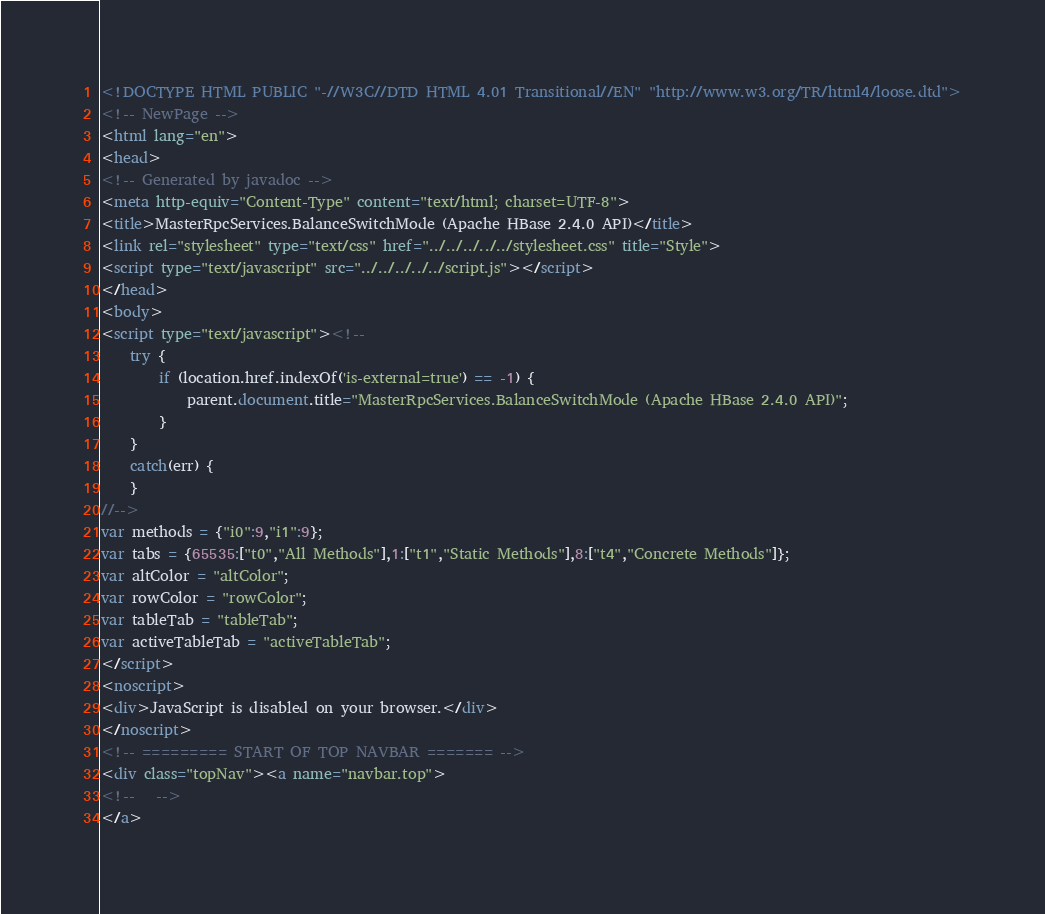Convert code to text. <code><loc_0><loc_0><loc_500><loc_500><_HTML_><!DOCTYPE HTML PUBLIC "-//W3C//DTD HTML 4.01 Transitional//EN" "http://www.w3.org/TR/html4/loose.dtd">
<!-- NewPage -->
<html lang="en">
<head>
<!-- Generated by javadoc -->
<meta http-equiv="Content-Type" content="text/html; charset=UTF-8">
<title>MasterRpcServices.BalanceSwitchMode (Apache HBase 2.4.0 API)</title>
<link rel="stylesheet" type="text/css" href="../../../../../stylesheet.css" title="Style">
<script type="text/javascript" src="../../../../../script.js"></script>
</head>
<body>
<script type="text/javascript"><!--
    try {
        if (location.href.indexOf('is-external=true') == -1) {
            parent.document.title="MasterRpcServices.BalanceSwitchMode (Apache HBase 2.4.0 API)";
        }
    }
    catch(err) {
    }
//-->
var methods = {"i0":9,"i1":9};
var tabs = {65535:["t0","All Methods"],1:["t1","Static Methods"],8:["t4","Concrete Methods"]};
var altColor = "altColor";
var rowColor = "rowColor";
var tableTab = "tableTab";
var activeTableTab = "activeTableTab";
</script>
<noscript>
<div>JavaScript is disabled on your browser.</div>
</noscript>
<!-- ========= START OF TOP NAVBAR ======= -->
<div class="topNav"><a name="navbar.top">
<!--   -->
</a></code> 